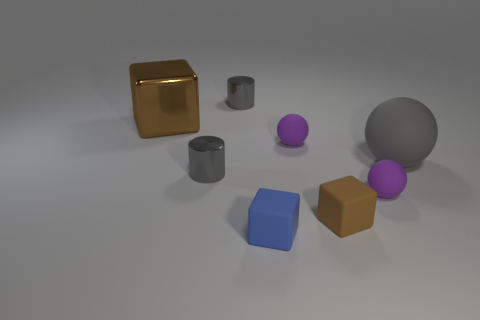There is a tiny matte cube behind the small blue rubber object; is it the same color as the matte ball that is on the left side of the brown matte thing?
Offer a terse response. No. There is a brown metal cube; how many brown metallic blocks are on the left side of it?
Offer a terse response. 0. There is another cube that is the same color as the shiny block; what material is it?
Make the answer very short. Rubber. Is there a gray shiny thing that has the same shape as the blue rubber object?
Make the answer very short. No. Is the material of the tiny block on the left side of the brown rubber thing the same as the brown thing on the right side of the shiny cube?
Your answer should be compact. Yes. There is a gray shiny object that is in front of the gray object that is right of the small cylinder that is behind the gray rubber ball; what size is it?
Ensure brevity in your answer.  Small. There is a thing that is the same size as the brown metal cube; what material is it?
Offer a terse response. Rubber. Are there any brown metal cubes that have the same size as the gray rubber object?
Offer a terse response. Yes. Is the shape of the big brown object the same as the tiny blue thing?
Offer a terse response. Yes. Are there any brown blocks in front of the object in front of the brown object on the right side of the small blue rubber thing?
Give a very brief answer. No. 